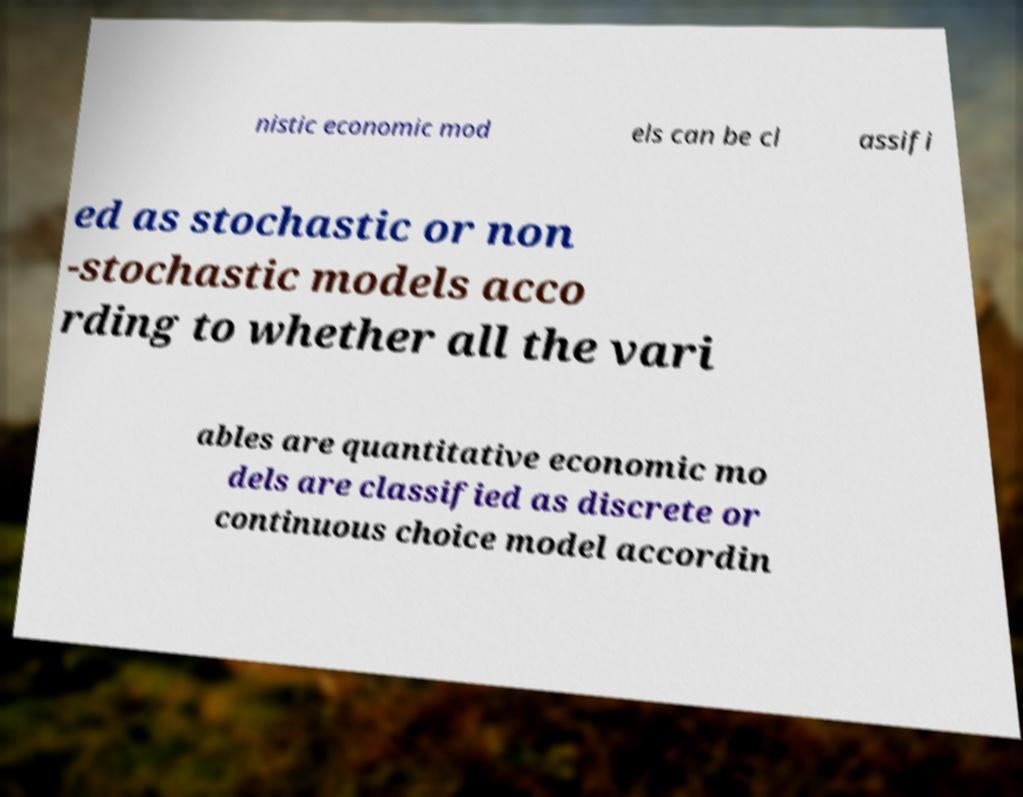Could you assist in decoding the text presented in this image and type it out clearly? nistic economic mod els can be cl assifi ed as stochastic or non -stochastic models acco rding to whether all the vari ables are quantitative economic mo dels are classified as discrete or continuous choice model accordin 